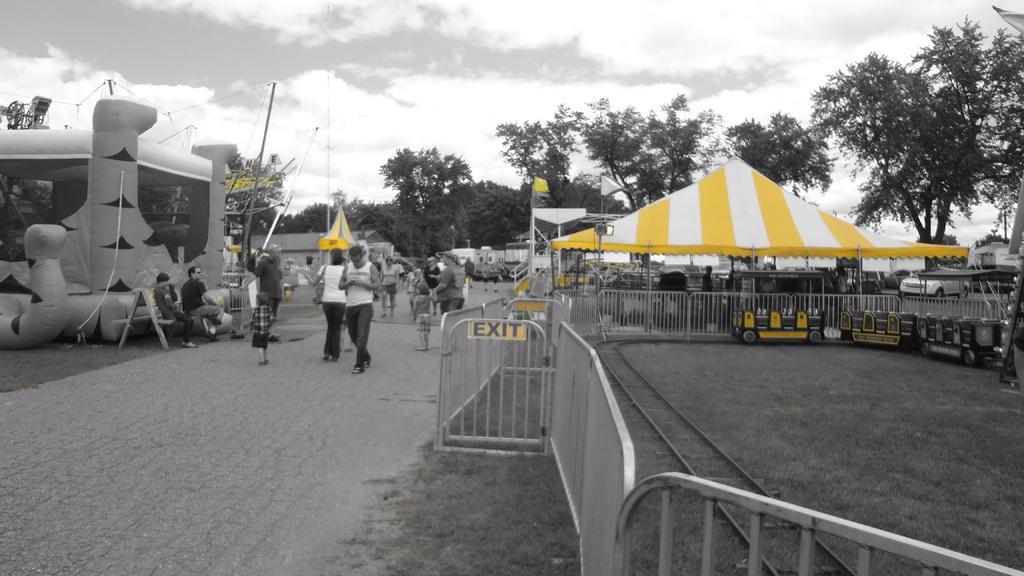In one or two sentences, can you explain what this image depicts? In the image we can see there are many people around, they are wearing clothes and shoes. We can even see there is grass, fence and a toy train. This is a pole tent, yellow and white in color. There are even many trees and a cloudy sky. 